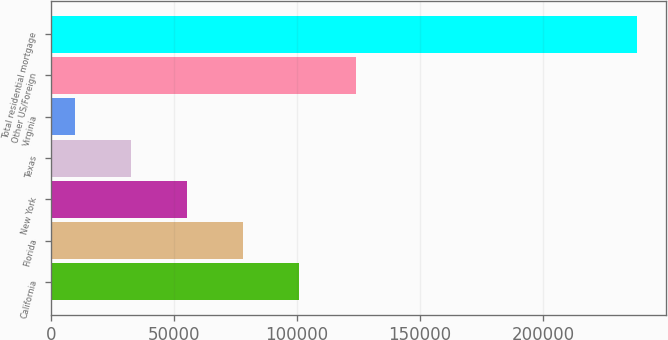Convert chart. <chart><loc_0><loc_0><loc_500><loc_500><bar_chart><fcel>California<fcel>Florida<fcel>New York<fcel>Texas<fcel>Virginia<fcel>Other US/Foreign<fcel>Total residential mortgage<nl><fcel>101038<fcel>78202.2<fcel>55366.8<fcel>32531.4<fcel>9696<fcel>123873<fcel>238050<nl></chart> 